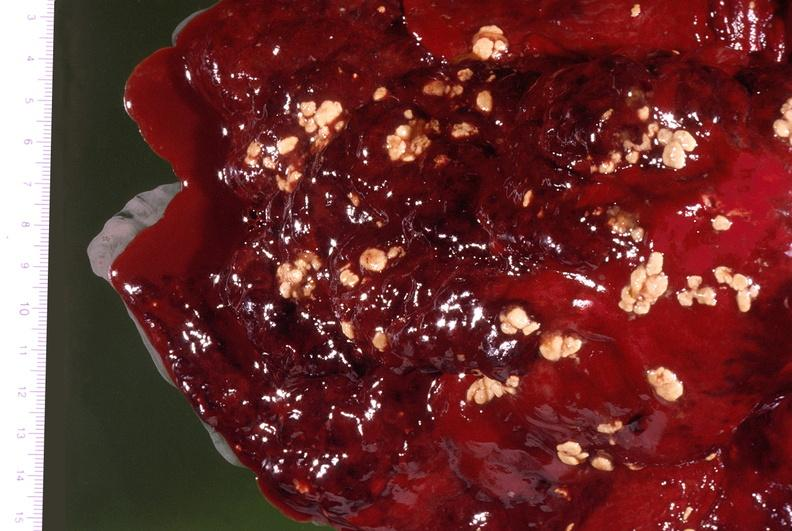what is present?
Answer the question using a single word or phrase. Respiratory 